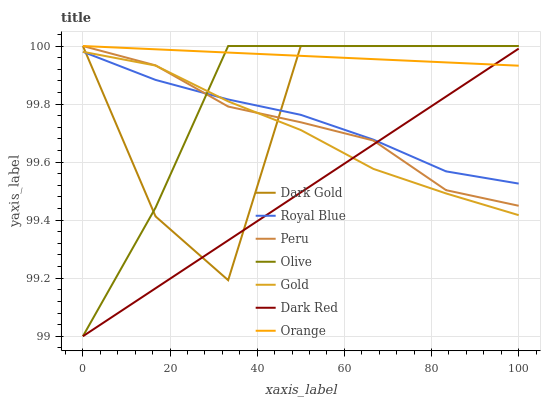Does Dark Red have the minimum area under the curve?
Answer yes or no. Yes. Does Orange have the maximum area under the curve?
Answer yes or no. Yes. Does Dark Gold have the minimum area under the curve?
Answer yes or no. No. Does Dark Gold have the maximum area under the curve?
Answer yes or no. No. Is Orange the smoothest?
Answer yes or no. Yes. Is Dark Gold the roughest?
Answer yes or no. Yes. Is Dark Red the smoothest?
Answer yes or no. No. Is Dark Red the roughest?
Answer yes or no. No. Does Dark Gold have the lowest value?
Answer yes or no. No. Does Orange have the highest value?
Answer yes or no. Yes. Does Dark Red have the highest value?
Answer yes or no. No. Is Gold less than Orange?
Answer yes or no. Yes. Is Orange greater than Royal Blue?
Answer yes or no. Yes. Does Royal Blue intersect Dark Red?
Answer yes or no. Yes. Is Royal Blue less than Dark Red?
Answer yes or no. No. Is Royal Blue greater than Dark Red?
Answer yes or no. No. Does Gold intersect Orange?
Answer yes or no. No. 